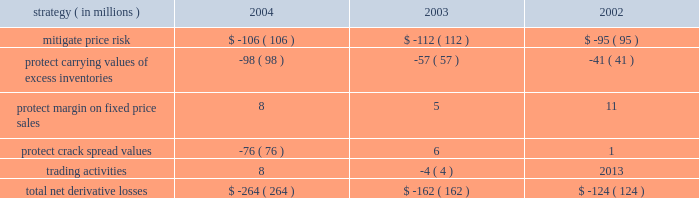Rm&t segment we do not attempt to qualify commodity derivative instruments used in our rm&t operations for hedge accounting .
As a result , we recognize all changes in the fair value of derivatives used in our rm&t operations in income , although most of these derivatives have an underlying physical commodity transaction .
Generally , derivative losses occur when market prices increase , which are offset by gains on the underlying physical commodity transactions .
Conversely , derivative gains occur when market prices decrease , which are offset by losses on the underlying physical commodity transactions .
Derivative gains or losses included in rm&t segment income for each of the last three years are summarized in the table : strategy ( in millions ) 2004 2003 2002 .
During 2004 , using derivative instruments map sold crack spreads forward through the fourth quarter 2005 at values higher than the company thought sustainable in the actual months these contracts expire .
Included in the $ 76 million derivative loss for 2004 noted in the above table for the 2018 2018protect crack spread values 2019 2019 strategy was approximately an $ 8 million gain due to changes in the fair value of crack-spread derivatives that will expire throughout 2005 .
In addition , natural gas options are in place to manage the price risk associated with approximately 41 percent of the first quarter 2005 anticipated natural gas purchases for refinery use .
Ig segment we have used derivative instruments to convert the fixed price of a long-term gas sales contract to market prices .
The underlying physical contract is for a specified annual quantity of gas and matures in 2008 .
Similarly , we will use derivative instruments to convert shorter term ( typically less than a year ) fixed price contracts to market prices in our ongoing purchase for resale activity ; and to hedge purchased gas injected into storage for subsequent resale .
Derivative gains included in ig segment income were $ 17 million in 2004 , compared to gains of $ 19 million in 2003 and losses of $ 8 million in 2002 .
Trading activity in the ig segment resulted in losses of $ 2 million in 2004 , compared to losses of $ 7 million in 2003 and gains of $ 4 million in 2002 and have been included in the aforementioned amounts .
Other commodity risk we are impacted by basis risk , caused by factors that affect the relationship between commodity futures prices reflected in derivative commodity instruments and the cash market price of the underlying commodity .
Natural gas transaction prices are frequently based on industry reference prices that may vary from prices experienced in local markets .
For example , new york mercantile exchange ( 2018 2018nymex 2019 2019 ) contracts for natural gas are priced at louisiana 2019s henry hub , while the underlying quantities of natural gas may be produced and sold in the western united states at prices that do not move in strict correlation with nymex prices .
If commodity price changes in one region are not reflected in other regions , derivative commodity instruments may no longer provide the expected hedge , resulting in increased exposure to basis risk .
These regional price differences could yield favorable or unfavorable results .
Otc transactions are being used to manage exposure to a portion of basis risk .
We are impacted by liquidity risk , caused by timing delays in liquidating contract positions due to a potential inability to identify a counterparty willing to accept an offsetting position .
Due to the large number of active participants , liquidity risk exposure is relatively low for exchange-traded transactions. .
What was the change in derivative gains included in ig segment income from 2004 , compared to 2003 , in millions? 
Computations: (17 - 19)
Answer: -2.0. 